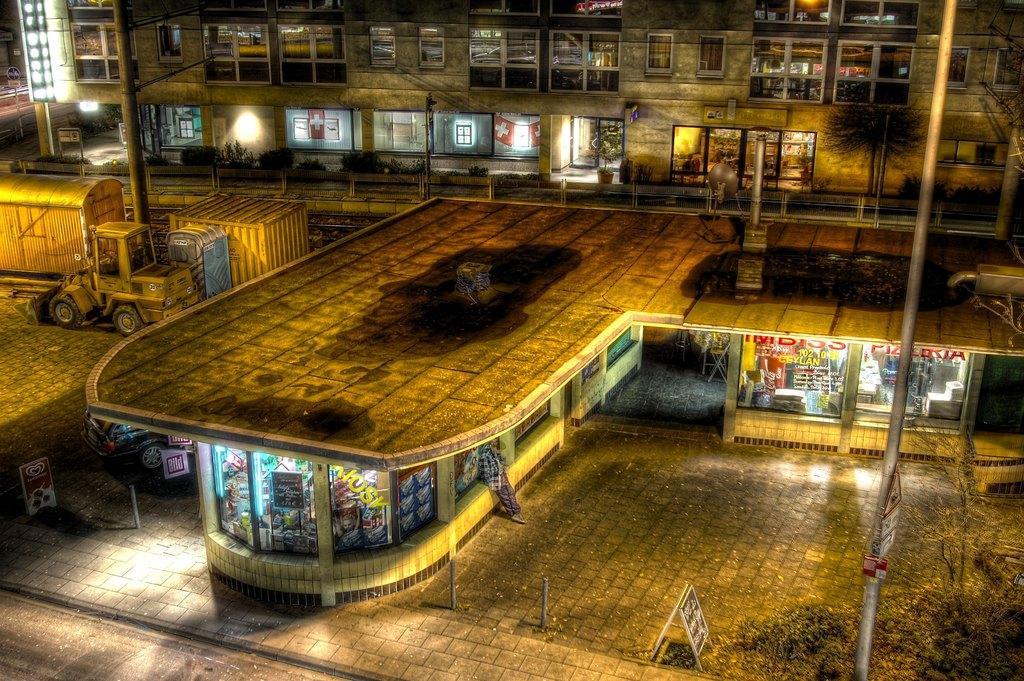Could you give a brief overview of what you see in this image? In this image, there are a few buildings, vehicles, boards, poles. We can see the ground with some objects. We can also see some grass and plants. We can also see some containers. 